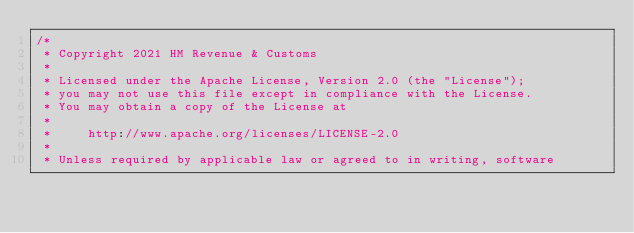<code> <loc_0><loc_0><loc_500><loc_500><_Scala_>/*
 * Copyright 2021 HM Revenue & Customs
 *
 * Licensed under the Apache License, Version 2.0 (the "License");
 * you may not use this file except in compliance with the License.
 * You may obtain a copy of the License at
 *
 *     http://www.apache.org/licenses/LICENSE-2.0
 *
 * Unless required by applicable law or agreed to in writing, software</code> 